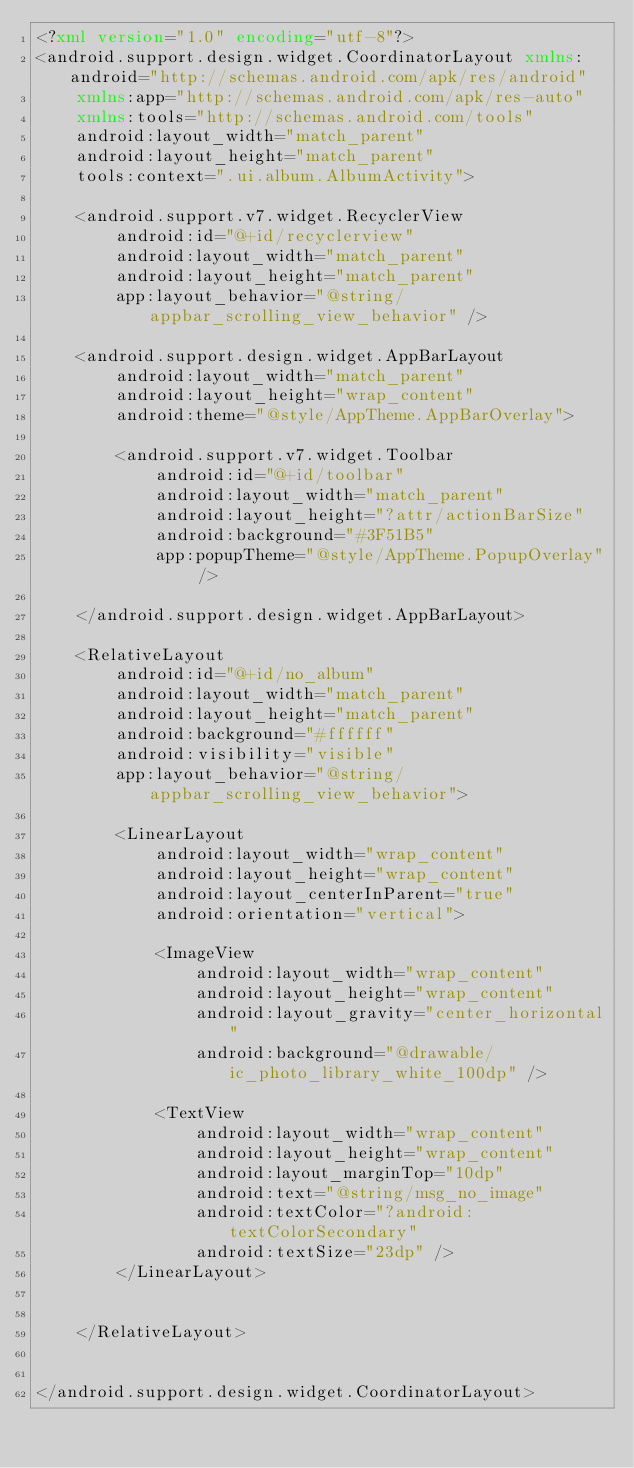Convert code to text. <code><loc_0><loc_0><loc_500><loc_500><_XML_><?xml version="1.0" encoding="utf-8"?>
<android.support.design.widget.CoordinatorLayout xmlns:android="http://schemas.android.com/apk/res/android"
    xmlns:app="http://schemas.android.com/apk/res-auto"
    xmlns:tools="http://schemas.android.com/tools"
    android:layout_width="match_parent"
    android:layout_height="match_parent"
    tools:context=".ui.album.AlbumActivity">

    <android.support.v7.widget.RecyclerView
        android:id="@+id/recyclerview"
        android:layout_width="match_parent"
        android:layout_height="match_parent"
        app:layout_behavior="@string/appbar_scrolling_view_behavior" />

    <android.support.design.widget.AppBarLayout
        android:layout_width="match_parent"
        android:layout_height="wrap_content"
        android:theme="@style/AppTheme.AppBarOverlay">

        <android.support.v7.widget.Toolbar
            android:id="@+id/toolbar"
            android:layout_width="match_parent"
            android:layout_height="?attr/actionBarSize"
            android:background="#3F51B5"
            app:popupTheme="@style/AppTheme.PopupOverlay" />

    </android.support.design.widget.AppBarLayout>

    <RelativeLayout
        android:id="@+id/no_album"
        android:layout_width="match_parent"
        android:layout_height="match_parent"
        android:background="#ffffff"
        android:visibility="visible"
        app:layout_behavior="@string/appbar_scrolling_view_behavior">

        <LinearLayout
            android:layout_width="wrap_content"
            android:layout_height="wrap_content"
            android:layout_centerInParent="true"
            android:orientation="vertical">

            <ImageView
                android:layout_width="wrap_content"
                android:layout_height="wrap_content"
                android:layout_gravity="center_horizontal"
                android:background="@drawable/ic_photo_library_white_100dp" />

            <TextView
                android:layout_width="wrap_content"
                android:layout_height="wrap_content"
                android:layout_marginTop="10dp"
                android:text="@string/msg_no_image"
                android:textColor="?android:textColorSecondary"
                android:textSize="23dp" />
        </LinearLayout>


    </RelativeLayout>


</android.support.design.widget.CoordinatorLayout></code> 